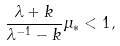<formula> <loc_0><loc_0><loc_500><loc_500>\frac { \lambda + k } { \lambda ^ { - 1 } - k } \mu _ { * } < 1 ,</formula> 